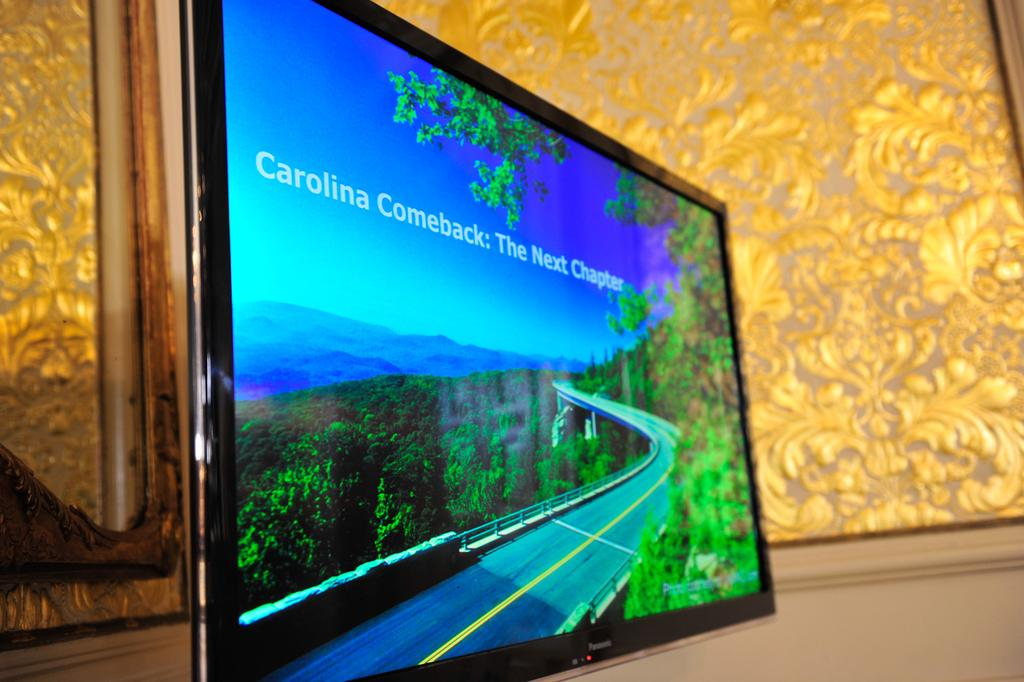Provide a one-sentence caption for the provided image. A tablet leaning on a wall with the screen reading Carolina Comeback:The Next Chapter on a scenic road with a trees surrounding. 